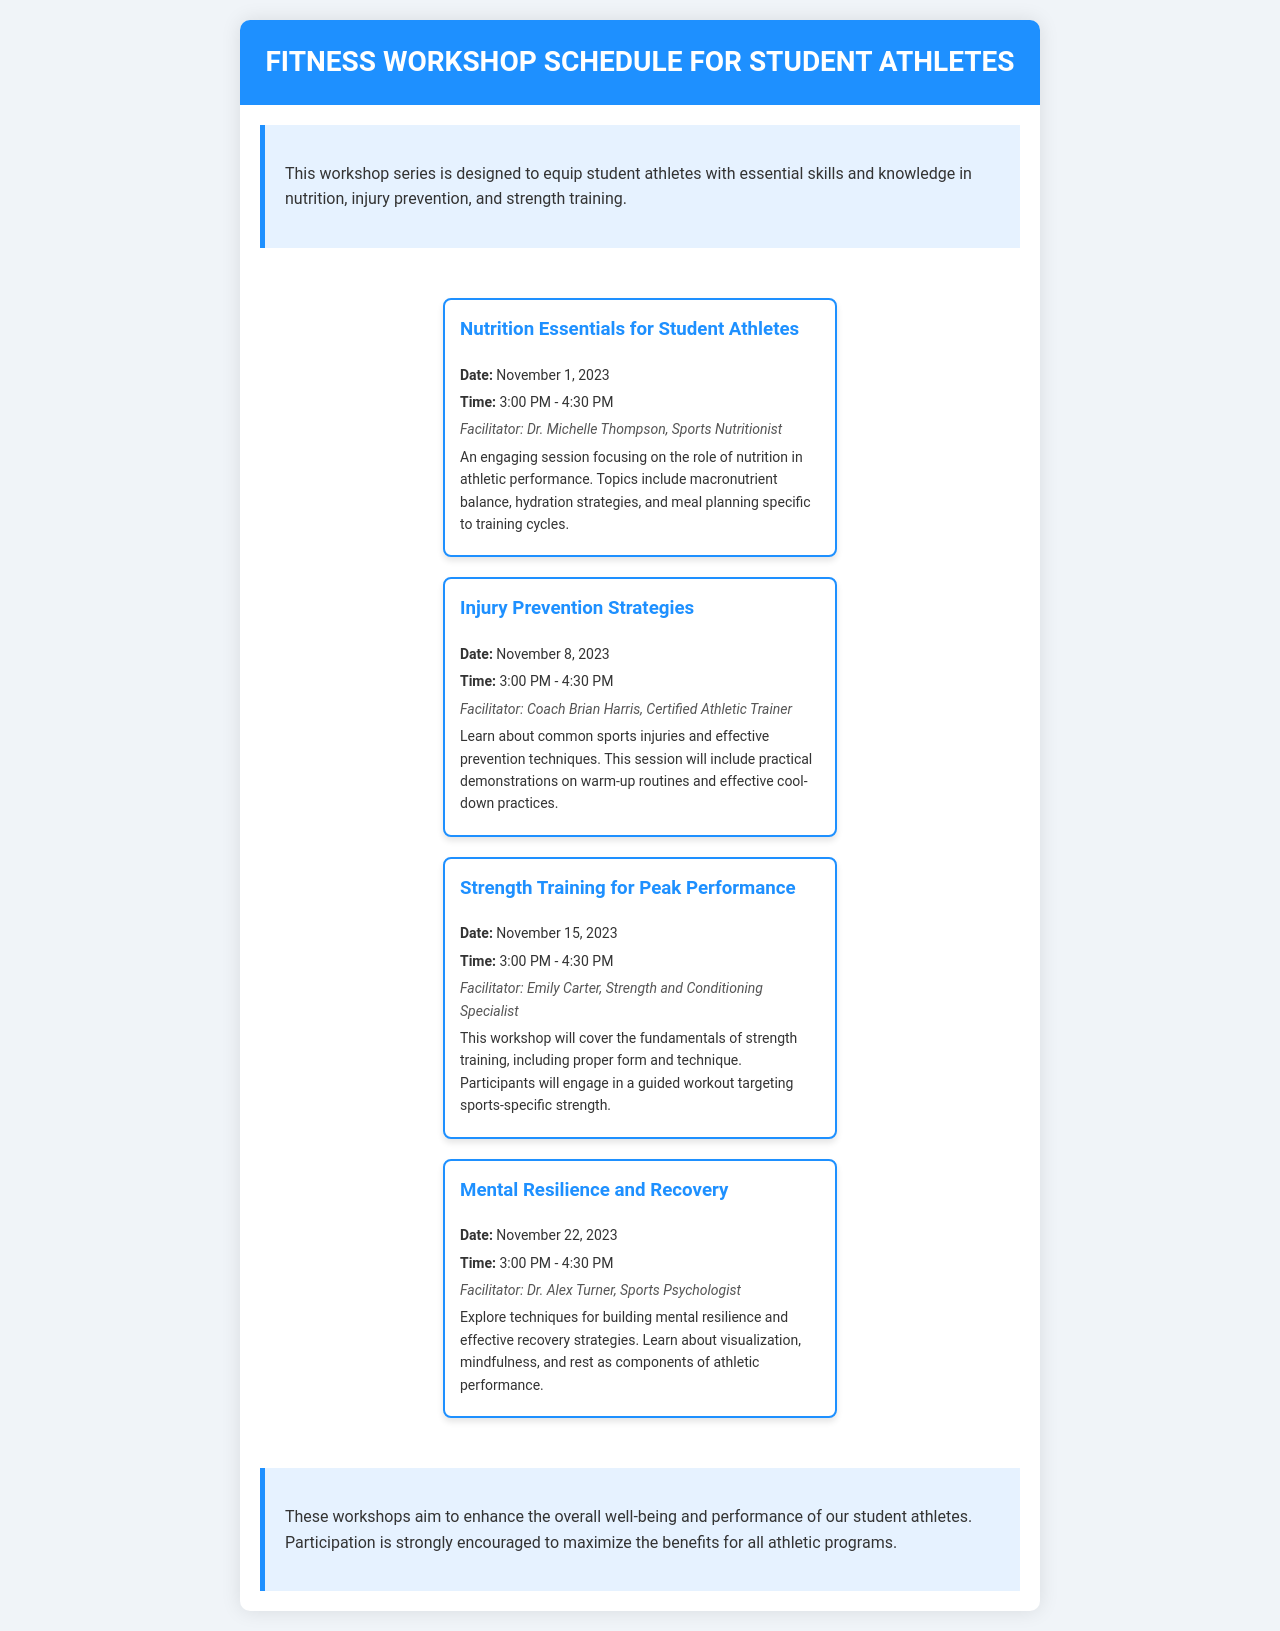What is the date for the Nutrition Essentials workshop? The date for the Nutrition Essentials workshop is provided directly in the schedule.
Answer: November 1, 2023 Who is the facilitator for the Injury Prevention Strategies session? The facilitator for the Injury Prevention Strategies session is listed in the session details.
Answer: Coach Brian Harris What time does the Strength Training workshop start? The start time for the Strength Training workshop is mentioned in the schedule.
Answer: 3:00 PM How many workshops are scheduled in total? The total number of workshops can be counted from the session sections in the document.
Answer: Four What is one technique discussed in the Mental Resilience and Recovery workshop? One of the techniques mentioned in the workshop description is highlighted as part of the session content.
Answer: Visualization What is the main focus of the workshops? The overall theme and objective of the workshops are described in the introductory section.
Answer: Essential skills and knowledge in nutrition, injury prevention, and strength training When is the last workshop scheduled? The date for the last workshop is provided in the schedule.
Answer: November 22, 2023 Who is the Strength and Conditioning Specialist for the Strength Training session? The name of the Strength and Conditioning Specialist is specified in the details of the session.
Answer: Emily Carter 